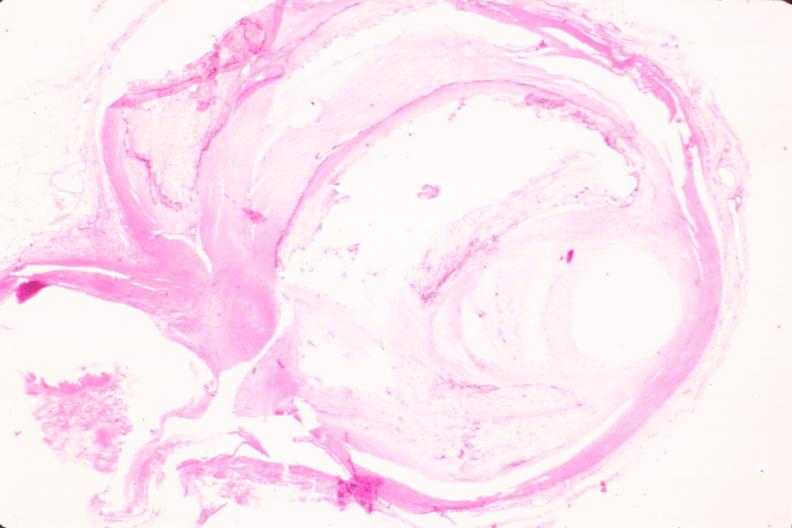where is this in?
Answer the question using a single word or phrase. In vasculature 